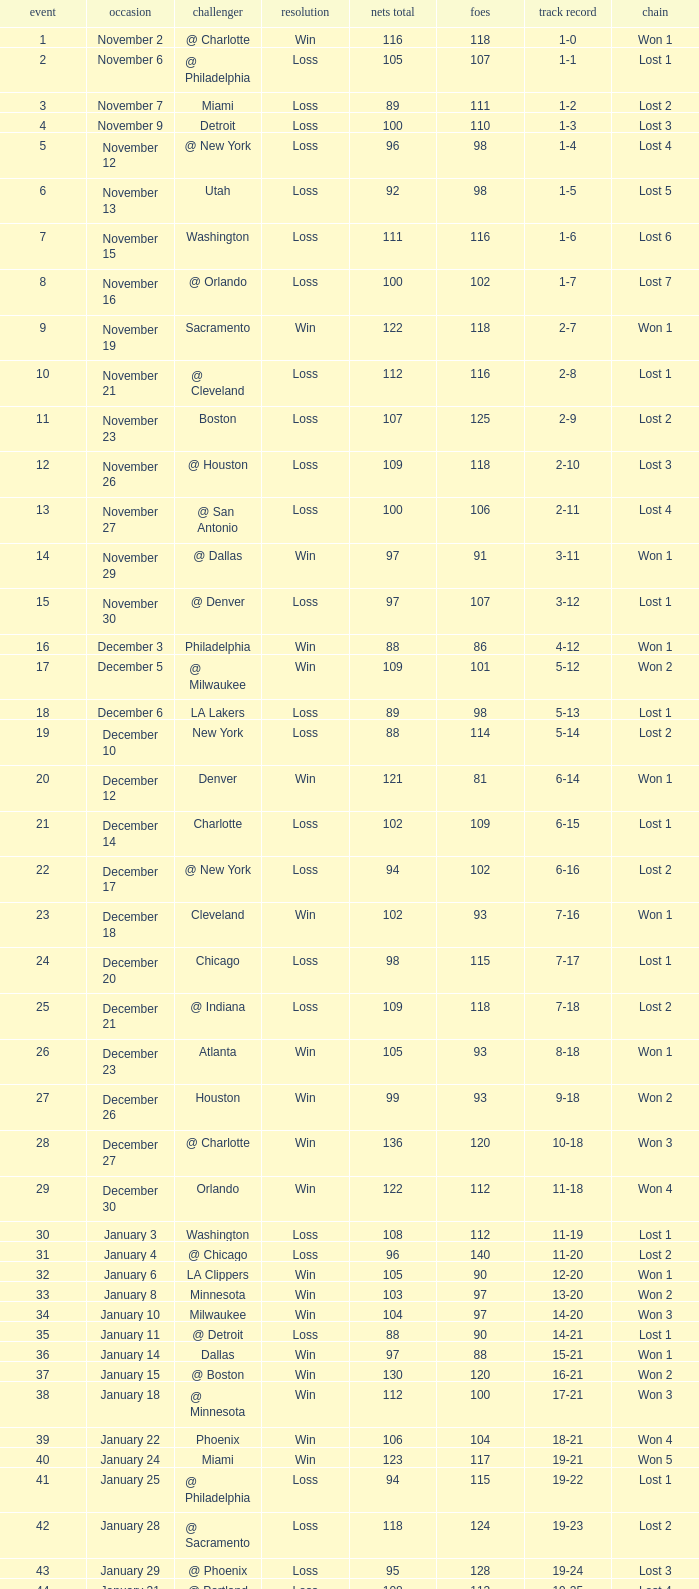Which opponent is from february 12? @ Philadelphia. 